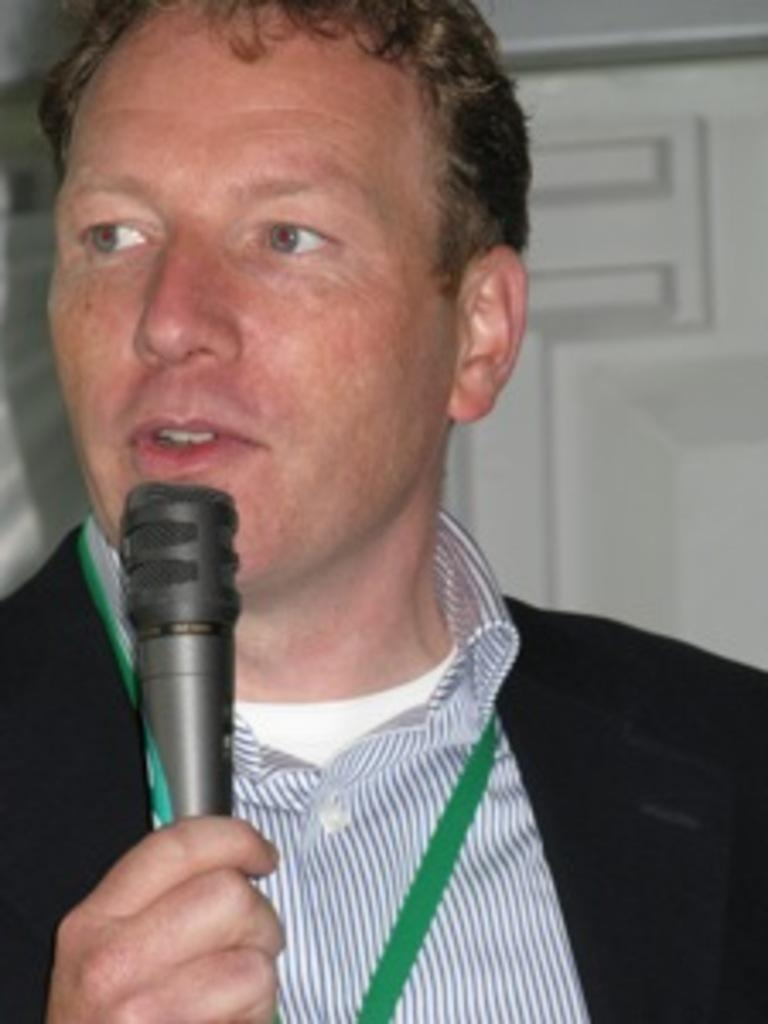Who is present in the image? There is a man in the image. What is the man holding in his hand? The man is holding a mic with his hand. Where is the cactus located in the image? There is no cactus present in the image. What is the man using to serve food in the image? The man is not using a tray to serve food in the image; he is holding a mic. 